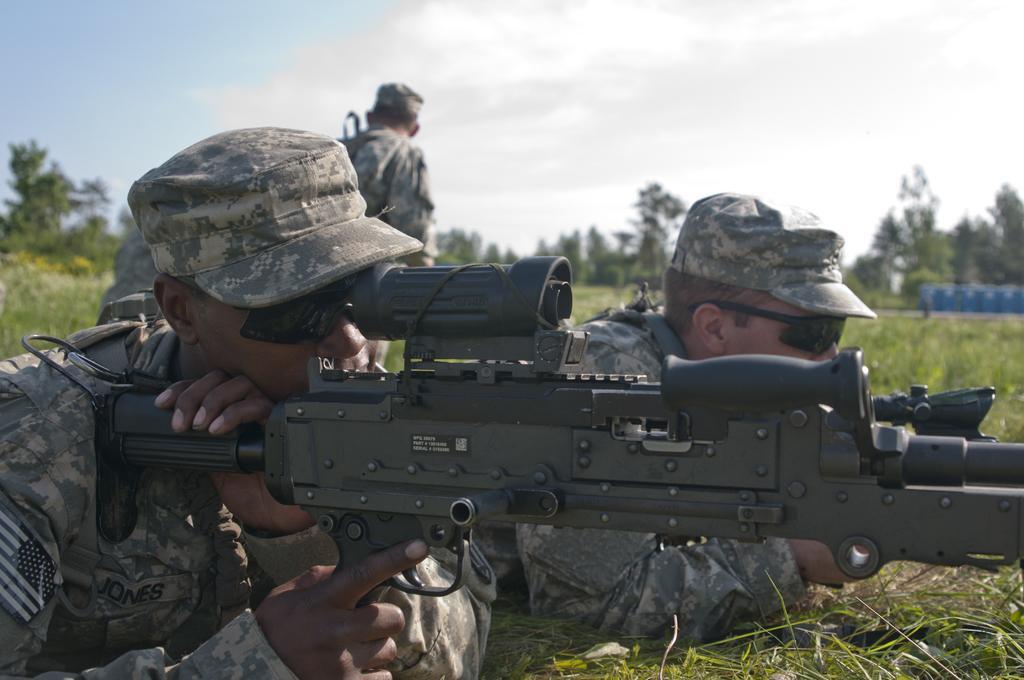Describe this image in one or two sentences. This image consists of two persons lying on the ground and holding the guns. At the bottom, there is green grass. In the background, there are trees. At the top, there is a sky. 